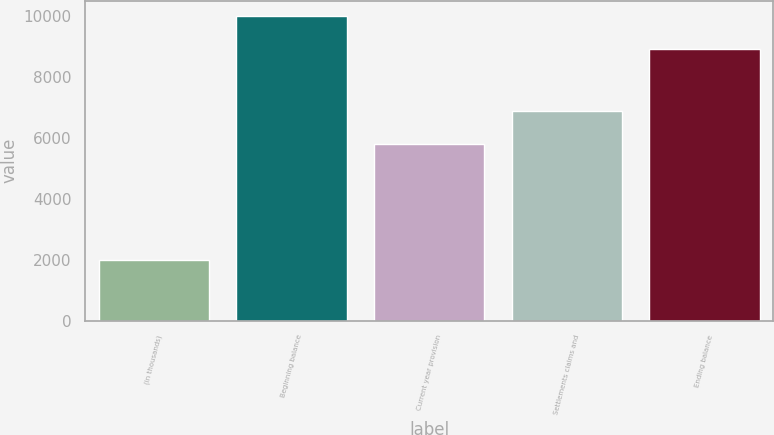<chart> <loc_0><loc_0><loc_500><loc_500><bar_chart><fcel>(in thousands)<fcel>Beginning balance<fcel>Current year provision<fcel>Settlements claims and<fcel>Ending balance<nl><fcel>2010<fcel>10000<fcel>5816<fcel>6891<fcel>8925<nl></chart> 